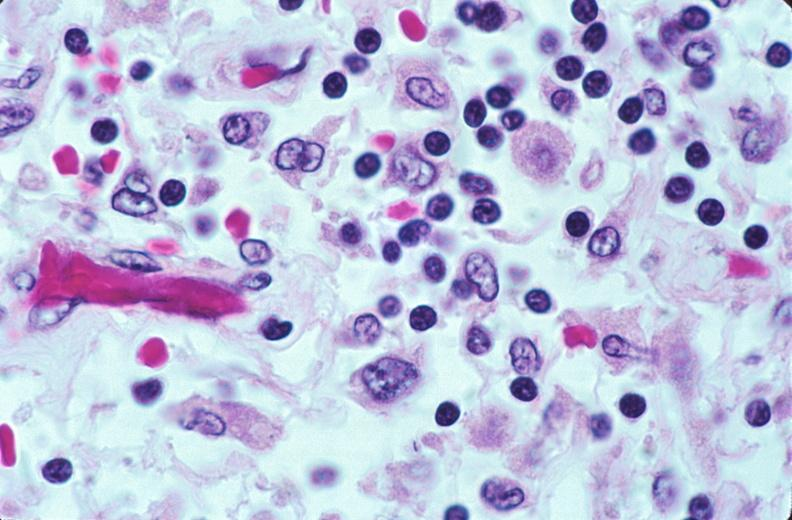does this image show lymph nodes, nodular sclerosing hodgkins disease?
Answer the question using a single word or phrase. Yes 